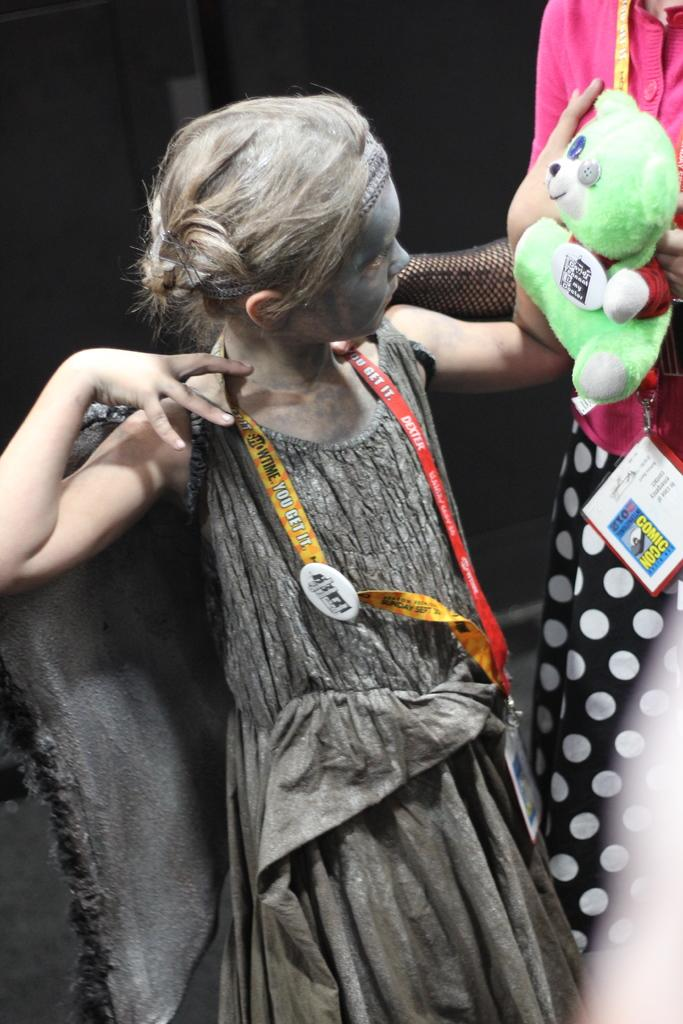What is the girl in the image holding? The girl is holding a teddy bear in the image. How is the girl interacting with the teddy bear? The girl is looking towards the teddy bear. Is there anyone else in the image with the girl holding the teddy bear? Yes, there is another girl standing beside her. What can be said about the second girl's clothing? The second girl is wearing a black and pink dress. How many oranges are on the girl's head in the image? There are no oranges present on the girl's head in the image. What is the feeling of the teddy bear in the image? The teddy bear is an inanimate object and does not have feelings. --- Facts: 1. There is a car in the image. 2. The car is red. 3. The car has four wheels. 4. There is a person sitting in the driver's seat. 5. The person is wearing a hat. Absurd Topics: parrot, dance, ocean Conversation: What is the main subject of the image? The main subject of the image is a car. What color is the car? The car is red. How many wheels does the car have? The car has four wheels. Is there anyone inside the car? Yes, there is a person sitting in the driver's seat. What can be said about the person's clothing or accessories? The person is wearing a hat. Reasoning: Let's think step by step in order to produce the conversation. We start by identifying the main subject in the image, which is the car. Then, we describe the car's color and the number of wheels it has. Next, we mention the presence of a person inside the car and provide a detail about their appearance, specifically the hat they are wearing. Each question is designed to elicit a specific detail about the image that is known from the provided facts. Absurd Question/Answer: Can you see a parrot dancing in the ocean in the image? There is no parrot or ocean present in the image. What type of dance is the car doing in the image? The car is an inanimate object and does not dance. 